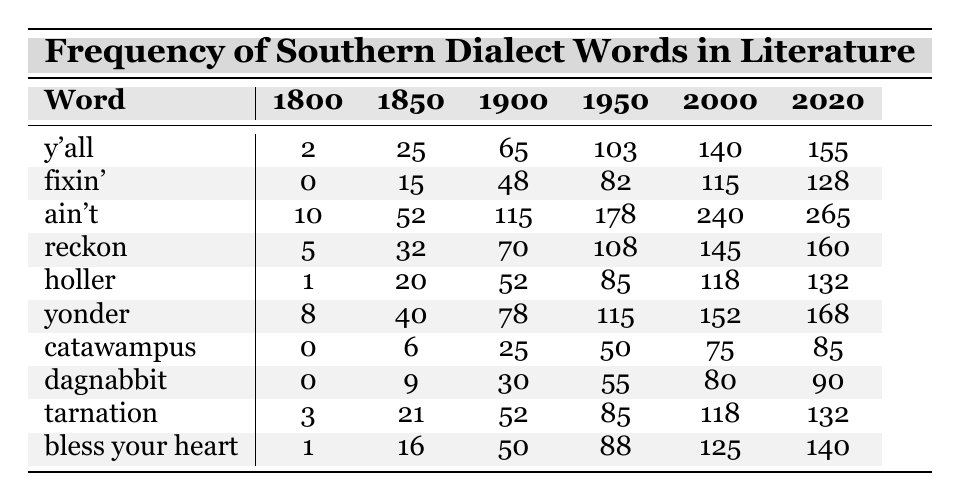What is the frequency of the word "y'all" in 1900? The table indicates that the frequency of "y'all" for the year 1900 is 65.
Answer: 65 Which word had the highest frequency in 2020? By examining the last column of the table, the word "ain't" has the highest frequency in 2020, which is 265.
Answer: ain't How many times was the word "holler" used in literature in 1950? The table shows that "holler" was used 85 times in literature in 1950.
Answer: 85 What is the difference in frequency of the word "fixin'" between 1850 and 2000? The frequency for "fixin'" in 1850 is 15 and in 2000 is 115. The difference is 115 - 15 = 100.
Answer: 100 What is the average frequency of the word "bless your heart" across all decades listed? Adding the frequencies for "bless your heart" (1, 16, 50, 88, 125, 140) gives 420. There are 6 decades, so the average is 420/6 = 70.
Answer: 70 True or false: The frequency of the word "dagnabbit" increased every decade from 1800 to 2020. Inspecting the frequencies for "dagnabbit," they are (0, 9, 30, 55, 80, 90); these values show consistent increases over the decades, confirming the statement is true.
Answer: True What was the trend for the word "tarnation" between 1800 and 1860? Analyzing the frequency for "tarnation" (3 in 1800 and 55 in 1860), we see it increased over the decades.
Answer: Increased Which word had a frequency of 0 in the 1800s? Looking closely at the table, "catawampus" and "dagnabbit" both had a frequency of 0 in 1800.
Answer: catawampus and dagnabbit What is the highest frequency recorded for the word "yonder" and in which decade did it occur? The highest frequency for "yonder" is 168, occurring in 2020.
Answer: 168 in 2020 Compare the frequencies of "reckon" in 1950 and 1980. Which decade had a higher usage? The frequency for "reckon" in 1950 is 108 and in 1980 is 145. Since 145 is greater than 108, 1980 had higher usage.
Answer: 1980 had higher usage 